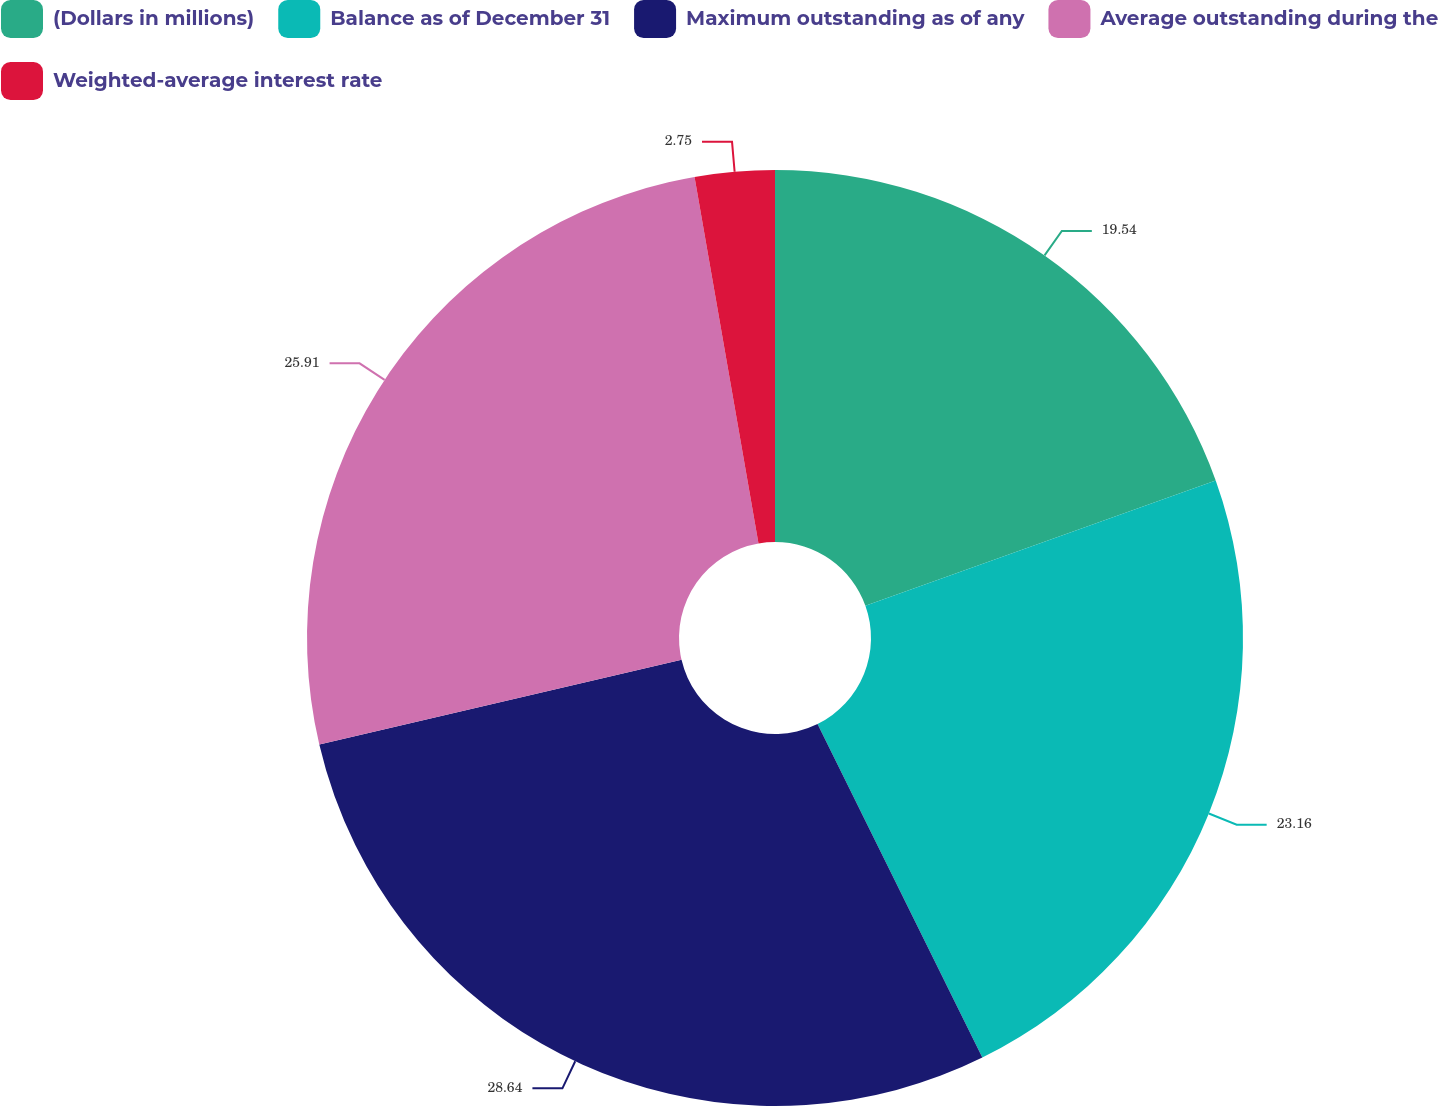<chart> <loc_0><loc_0><loc_500><loc_500><pie_chart><fcel>(Dollars in millions)<fcel>Balance as of December 31<fcel>Maximum outstanding as of any<fcel>Average outstanding during the<fcel>Weighted-average interest rate<nl><fcel>19.54%<fcel>23.16%<fcel>28.65%<fcel>25.91%<fcel>2.75%<nl></chart> 